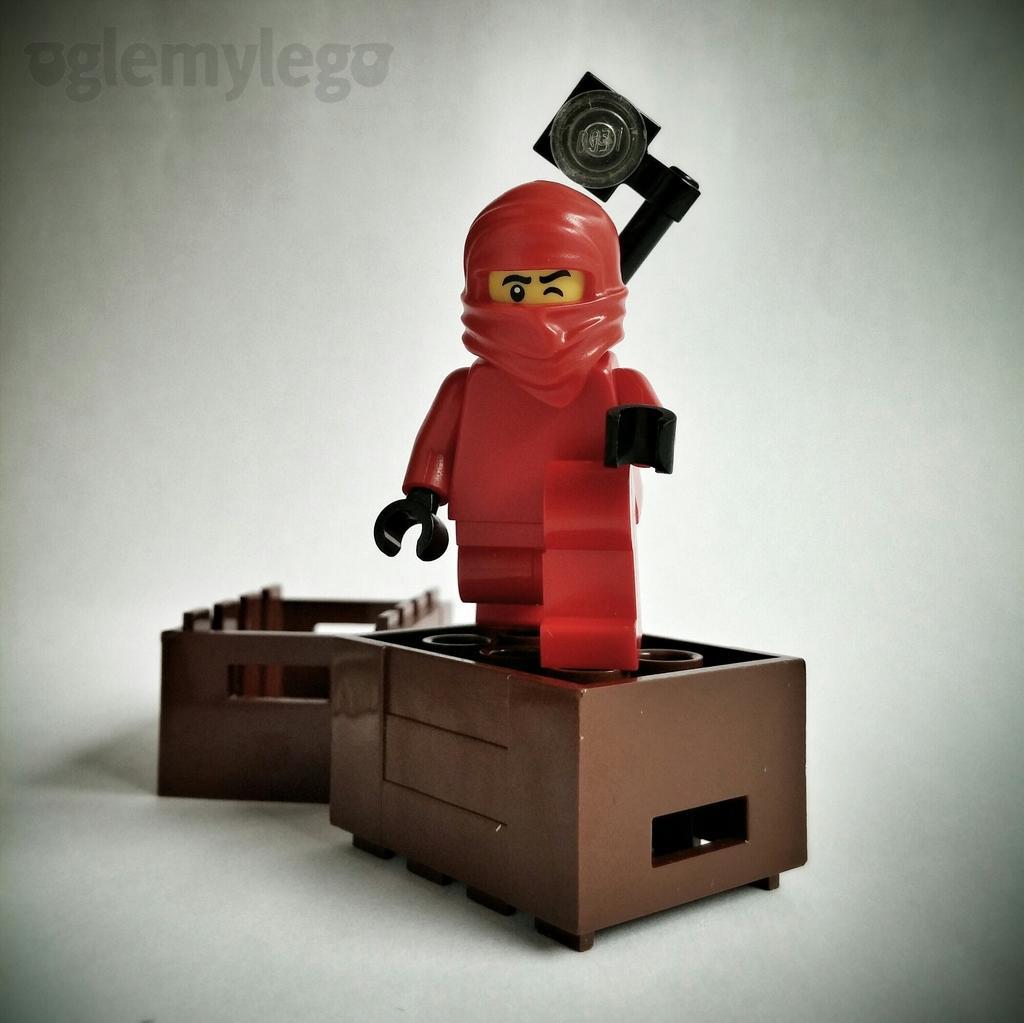Could you give a brief overview of what you see in this image? In this image, we can see a toy on the white background. 